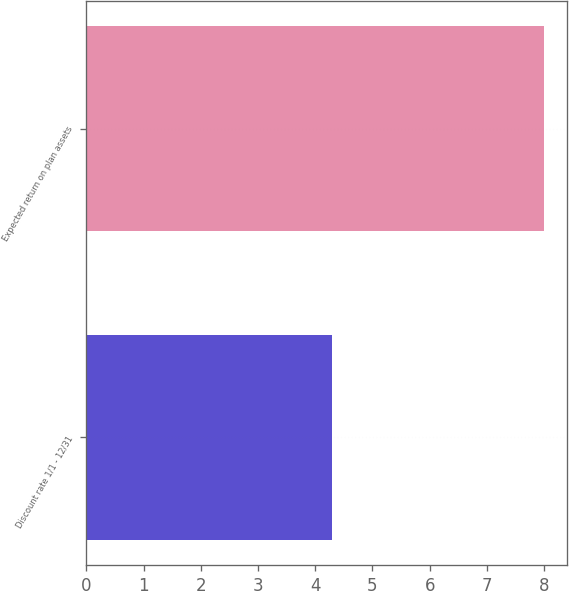<chart> <loc_0><loc_0><loc_500><loc_500><bar_chart><fcel>Discount rate 1/1 - 12/31<fcel>Expected return on plan assets<nl><fcel>4.3<fcel>8<nl></chart> 